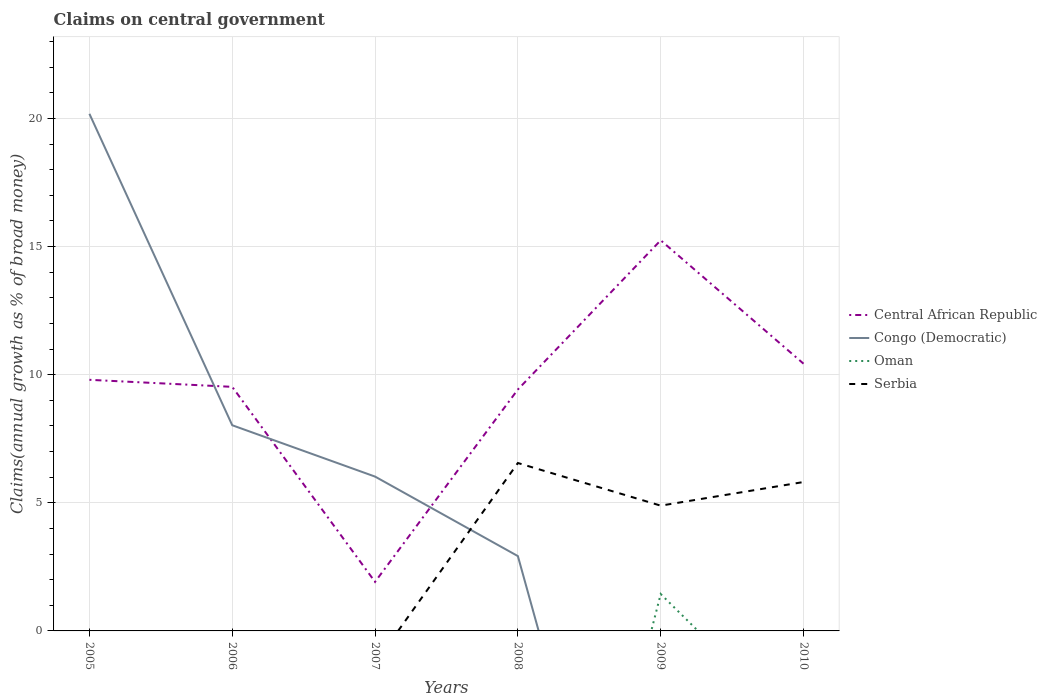Is the number of lines equal to the number of legend labels?
Offer a terse response. No. Across all years, what is the maximum percentage of broad money claimed on centeral government in Oman?
Provide a short and direct response. 0. What is the total percentage of broad money claimed on centeral government in Central African Republic in the graph?
Your answer should be compact. -5.82. What is the difference between the highest and the second highest percentage of broad money claimed on centeral government in Central African Republic?
Ensure brevity in your answer.  13.33. What is the difference between the highest and the lowest percentage of broad money claimed on centeral government in Congo (Democratic)?
Your answer should be very brief. 2. Is the percentage of broad money claimed on centeral government in Central African Republic strictly greater than the percentage of broad money claimed on centeral government in Serbia over the years?
Provide a short and direct response. No. How many years are there in the graph?
Your response must be concise. 6. What is the difference between two consecutive major ticks on the Y-axis?
Make the answer very short. 5. Where does the legend appear in the graph?
Offer a very short reply. Center right. How are the legend labels stacked?
Offer a very short reply. Vertical. What is the title of the graph?
Make the answer very short. Claims on central government. What is the label or title of the Y-axis?
Your answer should be compact. Claims(annual growth as % of broad money). What is the Claims(annual growth as % of broad money) of Central African Republic in 2005?
Provide a short and direct response. 9.8. What is the Claims(annual growth as % of broad money) of Congo (Democratic) in 2005?
Give a very brief answer. 20.18. What is the Claims(annual growth as % of broad money) in Oman in 2005?
Your response must be concise. 0. What is the Claims(annual growth as % of broad money) of Central African Republic in 2006?
Provide a succinct answer. 9.53. What is the Claims(annual growth as % of broad money) in Congo (Democratic) in 2006?
Your response must be concise. 8.03. What is the Claims(annual growth as % of broad money) of Oman in 2006?
Offer a terse response. 0. What is the Claims(annual growth as % of broad money) of Central African Republic in 2007?
Your response must be concise. 1.91. What is the Claims(annual growth as % of broad money) of Congo (Democratic) in 2007?
Make the answer very short. 6.02. What is the Claims(annual growth as % of broad money) of Central African Republic in 2008?
Offer a very short reply. 9.42. What is the Claims(annual growth as % of broad money) of Congo (Democratic) in 2008?
Your answer should be very brief. 2.92. What is the Claims(annual growth as % of broad money) of Oman in 2008?
Make the answer very short. 0. What is the Claims(annual growth as % of broad money) of Serbia in 2008?
Give a very brief answer. 6.55. What is the Claims(annual growth as % of broad money) of Central African Republic in 2009?
Your answer should be compact. 15.25. What is the Claims(annual growth as % of broad money) of Oman in 2009?
Make the answer very short. 1.44. What is the Claims(annual growth as % of broad money) of Serbia in 2009?
Your response must be concise. 4.89. What is the Claims(annual growth as % of broad money) in Central African Republic in 2010?
Make the answer very short. 10.43. What is the Claims(annual growth as % of broad money) of Congo (Democratic) in 2010?
Provide a succinct answer. 0. What is the Claims(annual growth as % of broad money) in Serbia in 2010?
Keep it short and to the point. 5.81. Across all years, what is the maximum Claims(annual growth as % of broad money) of Central African Republic?
Keep it short and to the point. 15.25. Across all years, what is the maximum Claims(annual growth as % of broad money) of Congo (Democratic)?
Ensure brevity in your answer.  20.18. Across all years, what is the maximum Claims(annual growth as % of broad money) of Oman?
Offer a very short reply. 1.44. Across all years, what is the maximum Claims(annual growth as % of broad money) in Serbia?
Keep it short and to the point. 6.55. Across all years, what is the minimum Claims(annual growth as % of broad money) in Central African Republic?
Make the answer very short. 1.91. Across all years, what is the minimum Claims(annual growth as % of broad money) of Congo (Democratic)?
Provide a succinct answer. 0. Across all years, what is the minimum Claims(annual growth as % of broad money) in Oman?
Make the answer very short. 0. Across all years, what is the minimum Claims(annual growth as % of broad money) of Serbia?
Give a very brief answer. 0. What is the total Claims(annual growth as % of broad money) of Central African Republic in the graph?
Provide a short and direct response. 56.34. What is the total Claims(annual growth as % of broad money) of Congo (Democratic) in the graph?
Your response must be concise. 37.16. What is the total Claims(annual growth as % of broad money) in Oman in the graph?
Give a very brief answer. 1.44. What is the total Claims(annual growth as % of broad money) in Serbia in the graph?
Offer a terse response. 17.26. What is the difference between the Claims(annual growth as % of broad money) of Central African Republic in 2005 and that in 2006?
Your answer should be very brief. 0.27. What is the difference between the Claims(annual growth as % of broad money) of Congo (Democratic) in 2005 and that in 2006?
Provide a succinct answer. 12.16. What is the difference between the Claims(annual growth as % of broad money) of Central African Republic in 2005 and that in 2007?
Your answer should be very brief. 7.89. What is the difference between the Claims(annual growth as % of broad money) of Congo (Democratic) in 2005 and that in 2007?
Offer a terse response. 14.16. What is the difference between the Claims(annual growth as % of broad money) in Central African Republic in 2005 and that in 2008?
Offer a terse response. 0.38. What is the difference between the Claims(annual growth as % of broad money) of Congo (Democratic) in 2005 and that in 2008?
Give a very brief answer. 17.26. What is the difference between the Claims(annual growth as % of broad money) of Central African Republic in 2005 and that in 2009?
Your answer should be compact. -5.45. What is the difference between the Claims(annual growth as % of broad money) of Central African Republic in 2005 and that in 2010?
Ensure brevity in your answer.  -0.63. What is the difference between the Claims(annual growth as % of broad money) in Central African Republic in 2006 and that in 2007?
Your response must be concise. 7.61. What is the difference between the Claims(annual growth as % of broad money) in Congo (Democratic) in 2006 and that in 2007?
Ensure brevity in your answer.  2. What is the difference between the Claims(annual growth as % of broad money) in Central African Republic in 2006 and that in 2008?
Your answer should be very brief. 0.1. What is the difference between the Claims(annual growth as % of broad money) of Congo (Democratic) in 2006 and that in 2008?
Provide a succinct answer. 5.11. What is the difference between the Claims(annual growth as % of broad money) in Central African Republic in 2006 and that in 2009?
Your answer should be compact. -5.72. What is the difference between the Claims(annual growth as % of broad money) of Central African Republic in 2006 and that in 2010?
Offer a terse response. -0.9. What is the difference between the Claims(annual growth as % of broad money) in Central African Republic in 2007 and that in 2008?
Offer a terse response. -7.51. What is the difference between the Claims(annual growth as % of broad money) of Congo (Democratic) in 2007 and that in 2008?
Provide a succinct answer. 3.1. What is the difference between the Claims(annual growth as % of broad money) of Central African Republic in 2007 and that in 2009?
Make the answer very short. -13.33. What is the difference between the Claims(annual growth as % of broad money) in Central African Republic in 2007 and that in 2010?
Ensure brevity in your answer.  -8.52. What is the difference between the Claims(annual growth as % of broad money) of Central African Republic in 2008 and that in 2009?
Your answer should be very brief. -5.82. What is the difference between the Claims(annual growth as % of broad money) in Serbia in 2008 and that in 2009?
Provide a short and direct response. 1.66. What is the difference between the Claims(annual growth as % of broad money) in Central African Republic in 2008 and that in 2010?
Ensure brevity in your answer.  -1.01. What is the difference between the Claims(annual growth as % of broad money) in Serbia in 2008 and that in 2010?
Make the answer very short. 0.74. What is the difference between the Claims(annual growth as % of broad money) of Central African Republic in 2009 and that in 2010?
Give a very brief answer. 4.82. What is the difference between the Claims(annual growth as % of broad money) of Serbia in 2009 and that in 2010?
Keep it short and to the point. -0.92. What is the difference between the Claims(annual growth as % of broad money) of Central African Republic in 2005 and the Claims(annual growth as % of broad money) of Congo (Democratic) in 2006?
Your response must be concise. 1.77. What is the difference between the Claims(annual growth as % of broad money) in Central African Republic in 2005 and the Claims(annual growth as % of broad money) in Congo (Democratic) in 2007?
Your response must be concise. 3.78. What is the difference between the Claims(annual growth as % of broad money) in Central African Republic in 2005 and the Claims(annual growth as % of broad money) in Congo (Democratic) in 2008?
Give a very brief answer. 6.88. What is the difference between the Claims(annual growth as % of broad money) of Central African Republic in 2005 and the Claims(annual growth as % of broad money) of Serbia in 2008?
Give a very brief answer. 3.25. What is the difference between the Claims(annual growth as % of broad money) of Congo (Democratic) in 2005 and the Claims(annual growth as % of broad money) of Serbia in 2008?
Give a very brief answer. 13.63. What is the difference between the Claims(annual growth as % of broad money) in Central African Republic in 2005 and the Claims(annual growth as % of broad money) in Oman in 2009?
Offer a very short reply. 8.36. What is the difference between the Claims(annual growth as % of broad money) in Central African Republic in 2005 and the Claims(annual growth as % of broad money) in Serbia in 2009?
Make the answer very short. 4.91. What is the difference between the Claims(annual growth as % of broad money) of Congo (Democratic) in 2005 and the Claims(annual growth as % of broad money) of Oman in 2009?
Your answer should be very brief. 18.74. What is the difference between the Claims(annual growth as % of broad money) in Congo (Democratic) in 2005 and the Claims(annual growth as % of broad money) in Serbia in 2009?
Keep it short and to the point. 15.29. What is the difference between the Claims(annual growth as % of broad money) in Central African Republic in 2005 and the Claims(annual growth as % of broad money) in Serbia in 2010?
Provide a short and direct response. 3.99. What is the difference between the Claims(annual growth as % of broad money) in Congo (Democratic) in 2005 and the Claims(annual growth as % of broad money) in Serbia in 2010?
Your answer should be compact. 14.37. What is the difference between the Claims(annual growth as % of broad money) in Central African Republic in 2006 and the Claims(annual growth as % of broad money) in Congo (Democratic) in 2007?
Ensure brevity in your answer.  3.5. What is the difference between the Claims(annual growth as % of broad money) of Central African Republic in 2006 and the Claims(annual growth as % of broad money) of Congo (Democratic) in 2008?
Your answer should be compact. 6.61. What is the difference between the Claims(annual growth as % of broad money) of Central African Republic in 2006 and the Claims(annual growth as % of broad money) of Serbia in 2008?
Make the answer very short. 2.97. What is the difference between the Claims(annual growth as % of broad money) in Congo (Democratic) in 2006 and the Claims(annual growth as % of broad money) in Serbia in 2008?
Ensure brevity in your answer.  1.47. What is the difference between the Claims(annual growth as % of broad money) in Central African Republic in 2006 and the Claims(annual growth as % of broad money) in Oman in 2009?
Offer a very short reply. 8.09. What is the difference between the Claims(annual growth as % of broad money) of Central African Republic in 2006 and the Claims(annual growth as % of broad money) of Serbia in 2009?
Your answer should be compact. 4.64. What is the difference between the Claims(annual growth as % of broad money) in Congo (Democratic) in 2006 and the Claims(annual growth as % of broad money) in Oman in 2009?
Your answer should be very brief. 6.59. What is the difference between the Claims(annual growth as % of broad money) in Congo (Democratic) in 2006 and the Claims(annual growth as % of broad money) in Serbia in 2009?
Your response must be concise. 3.14. What is the difference between the Claims(annual growth as % of broad money) of Central African Republic in 2006 and the Claims(annual growth as % of broad money) of Serbia in 2010?
Provide a succinct answer. 3.72. What is the difference between the Claims(annual growth as % of broad money) of Congo (Democratic) in 2006 and the Claims(annual growth as % of broad money) of Serbia in 2010?
Provide a short and direct response. 2.22. What is the difference between the Claims(annual growth as % of broad money) in Central African Republic in 2007 and the Claims(annual growth as % of broad money) in Congo (Democratic) in 2008?
Offer a terse response. -1.01. What is the difference between the Claims(annual growth as % of broad money) in Central African Republic in 2007 and the Claims(annual growth as % of broad money) in Serbia in 2008?
Provide a succinct answer. -4.64. What is the difference between the Claims(annual growth as % of broad money) of Congo (Democratic) in 2007 and the Claims(annual growth as % of broad money) of Serbia in 2008?
Ensure brevity in your answer.  -0.53. What is the difference between the Claims(annual growth as % of broad money) of Central African Republic in 2007 and the Claims(annual growth as % of broad money) of Oman in 2009?
Offer a terse response. 0.47. What is the difference between the Claims(annual growth as % of broad money) in Central African Republic in 2007 and the Claims(annual growth as % of broad money) in Serbia in 2009?
Provide a succinct answer. -2.98. What is the difference between the Claims(annual growth as % of broad money) of Congo (Democratic) in 2007 and the Claims(annual growth as % of broad money) of Oman in 2009?
Your answer should be compact. 4.58. What is the difference between the Claims(annual growth as % of broad money) in Congo (Democratic) in 2007 and the Claims(annual growth as % of broad money) in Serbia in 2009?
Offer a very short reply. 1.13. What is the difference between the Claims(annual growth as % of broad money) in Central African Republic in 2007 and the Claims(annual growth as % of broad money) in Serbia in 2010?
Make the answer very short. -3.9. What is the difference between the Claims(annual growth as % of broad money) of Congo (Democratic) in 2007 and the Claims(annual growth as % of broad money) of Serbia in 2010?
Your answer should be compact. 0.21. What is the difference between the Claims(annual growth as % of broad money) in Central African Republic in 2008 and the Claims(annual growth as % of broad money) in Oman in 2009?
Offer a very short reply. 7.98. What is the difference between the Claims(annual growth as % of broad money) in Central African Republic in 2008 and the Claims(annual growth as % of broad money) in Serbia in 2009?
Give a very brief answer. 4.53. What is the difference between the Claims(annual growth as % of broad money) in Congo (Democratic) in 2008 and the Claims(annual growth as % of broad money) in Oman in 2009?
Make the answer very short. 1.48. What is the difference between the Claims(annual growth as % of broad money) of Congo (Democratic) in 2008 and the Claims(annual growth as % of broad money) of Serbia in 2009?
Keep it short and to the point. -1.97. What is the difference between the Claims(annual growth as % of broad money) in Central African Republic in 2008 and the Claims(annual growth as % of broad money) in Serbia in 2010?
Your answer should be very brief. 3.61. What is the difference between the Claims(annual growth as % of broad money) in Congo (Democratic) in 2008 and the Claims(annual growth as % of broad money) in Serbia in 2010?
Provide a succinct answer. -2.89. What is the difference between the Claims(annual growth as % of broad money) in Central African Republic in 2009 and the Claims(annual growth as % of broad money) in Serbia in 2010?
Ensure brevity in your answer.  9.44. What is the difference between the Claims(annual growth as % of broad money) in Oman in 2009 and the Claims(annual growth as % of broad money) in Serbia in 2010?
Your response must be concise. -4.37. What is the average Claims(annual growth as % of broad money) in Central African Republic per year?
Offer a very short reply. 9.39. What is the average Claims(annual growth as % of broad money) in Congo (Democratic) per year?
Your response must be concise. 6.19. What is the average Claims(annual growth as % of broad money) of Oman per year?
Ensure brevity in your answer.  0.24. What is the average Claims(annual growth as % of broad money) of Serbia per year?
Your response must be concise. 2.88. In the year 2005, what is the difference between the Claims(annual growth as % of broad money) of Central African Republic and Claims(annual growth as % of broad money) of Congo (Democratic)?
Your response must be concise. -10.38. In the year 2006, what is the difference between the Claims(annual growth as % of broad money) of Central African Republic and Claims(annual growth as % of broad money) of Congo (Democratic)?
Offer a terse response. 1.5. In the year 2007, what is the difference between the Claims(annual growth as % of broad money) of Central African Republic and Claims(annual growth as % of broad money) of Congo (Democratic)?
Offer a very short reply. -4.11. In the year 2008, what is the difference between the Claims(annual growth as % of broad money) in Central African Republic and Claims(annual growth as % of broad money) in Congo (Democratic)?
Offer a terse response. 6.5. In the year 2008, what is the difference between the Claims(annual growth as % of broad money) of Central African Republic and Claims(annual growth as % of broad money) of Serbia?
Provide a succinct answer. 2.87. In the year 2008, what is the difference between the Claims(annual growth as % of broad money) in Congo (Democratic) and Claims(annual growth as % of broad money) in Serbia?
Your answer should be compact. -3.63. In the year 2009, what is the difference between the Claims(annual growth as % of broad money) of Central African Republic and Claims(annual growth as % of broad money) of Oman?
Give a very brief answer. 13.81. In the year 2009, what is the difference between the Claims(annual growth as % of broad money) of Central African Republic and Claims(annual growth as % of broad money) of Serbia?
Ensure brevity in your answer.  10.36. In the year 2009, what is the difference between the Claims(annual growth as % of broad money) of Oman and Claims(annual growth as % of broad money) of Serbia?
Your response must be concise. -3.45. In the year 2010, what is the difference between the Claims(annual growth as % of broad money) of Central African Republic and Claims(annual growth as % of broad money) of Serbia?
Your response must be concise. 4.62. What is the ratio of the Claims(annual growth as % of broad money) of Central African Republic in 2005 to that in 2006?
Offer a very short reply. 1.03. What is the ratio of the Claims(annual growth as % of broad money) of Congo (Democratic) in 2005 to that in 2006?
Your answer should be very brief. 2.51. What is the ratio of the Claims(annual growth as % of broad money) in Central African Republic in 2005 to that in 2007?
Keep it short and to the point. 5.12. What is the ratio of the Claims(annual growth as % of broad money) in Congo (Democratic) in 2005 to that in 2007?
Your answer should be compact. 3.35. What is the ratio of the Claims(annual growth as % of broad money) of Central African Republic in 2005 to that in 2008?
Give a very brief answer. 1.04. What is the ratio of the Claims(annual growth as % of broad money) of Congo (Democratic) in 2005 to that in 2008?
Give a very brief answer. 6.91. What is the ratio of the Claims(annual growth as % of broad money) in Central African Republic in 2005 to that in 2009?
Provide a succinct answer. 0.64. What is the ratio of the Claims(annual growth as % of broad money) in Central African Republic in 2005 to that in 2010?
Your answer should be very brief. 0.94. What is the ratio of the Claims(annual growth as % of broad money) of Central African Republic in 2006 to that in 2007?
Provide a short and direct response. 4.98. What is the ratio of the Claims(annual growth as % of broad money) in Congo (Democratic) in 2006 to that in 2007?
Ensure brevity in your answer.  1.33. What is the ratio of the Claims(annual growth as % of broad money) of Central African Republic in 2006 to that in 2008?
Your answer should be compact. 1.01. What is the ratio of the Claims(annual growth as % of broad money) of Congo (Democratic) in 2006 to that in 2008?
Ensure brevity in your answer.  2.75. What is the ratio of the Claims(annual growth as % of broad money) in Central African Republic in 2006 to that in 2009?
Provide a succinct answer. 0.62. What is the ratio of the Claims(annual growth as % of broad money) in Central African Republic in 2006 to that in 2010?
Offer a terse response. 0.91. What is the ratio of the Claims(annual growth as % of broad money) in Central African Republic in 2007 to that in 2008?
Your response must be concise. 0.2. What is the ratio of the Claims(annual growth as % of broad money) of Congo (Democratic) in 2007 to that in 2008?
Your response must be concise. 2.06. What is the ratio of the Claims(annual growth as % of broad money) in Central African Republic in 2007 to that in 2009?
Your answer should be compact. 0.13. What is the ratio of the Claims(annual growth as % of broad money) in Central African Republic in 2007 to that in 2010?
Ensure brevity in your answer.  0.18. What is the ratio of the Claims(annual growth as % of broad money) in Central African Republic in 2008 to that in 2009?
Keep it short and to the point. 0.62. What is the ratio of the Claims(annual growth as % of broad money) of Serbia in 2008 to that in 2009?
Your answer should be compact. 1.34. What is the ratio of the Claims(annual growth as % of broad money) of Central African Republic in 2008 to that in 2010?
Offer a terse response. 0.9. What is the ratio of the Claims(annual growth as % of broad money) in Serbia in 2008 to that in 2010?
Your response must be concise. 1.13. What is the ratio of the Claims(annual growth as % of broad money) in Central African Republic in 2009 to that in 2010?
Provide a short and direct response. 1.46. What is the ratio of the Claims(annual growth as % of broad money) of Serbia in 2009 to that in 2010?
Keep it short and to the point. 0.84. What is the difference between the highest and the second highest Claims(annual growth as % of broad money) of Central African Republic?
Keep it short and to the point. 4.82. What is the difference between the highest and the second highest Claims(annual growth as % of broad money) of Congo (Democratic)?
Your answer should be compact. 12.16. What is the difference between the highest and the second highest Claims(annual growth as % of broad money) in Serbia?
Offer a terse response. 0.74. What is the difference between the highest and the lowest Claims(annual growth as % of broad money) in Central African Republic?
Provide a succinct answer. 13.33. What is the difference between the highest and the lowest Claims(annual growth as % of broad money) in Congo (Democratic)?
Your answer should be very brief. 20.18. What is the difference between the highest and the lowest Claims(annual growth as % of broad money) of Oman?
Your response must be concise. 1.44. What is the difference between the highest and the lowest Claims(annual growth as % of broad money) of Serbia?
Your response must be concise. 6.55. 